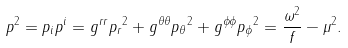<formula> <loc_0><loc_0><loc_500><loc_500>p ^ { 2 } = p _ { i } p ^ { i } = g ^ { r r } { p _ { r } } ^ { 2 } + g ^ { \theta \theta } { p _ { \theta } } ^ { 2 } + g ^ { \phi \phi } { p _ { \phi } } ^ { 2 } = \frac { \omega ^ { 2 } } { f } - \mu ^ { 2 } .</formula> 